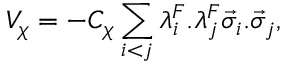<formula> <loc_0><loc_0><loc_500><loc_500>V _ { \chi } = - C _ { \chi } \sum _ { i < j } \lambda _ { i } ^ { F } . \lambda _ { j } ^ { F } \vec { \sigma } _ { i } . \vec { \sigma } _ { j } ,</formula> 